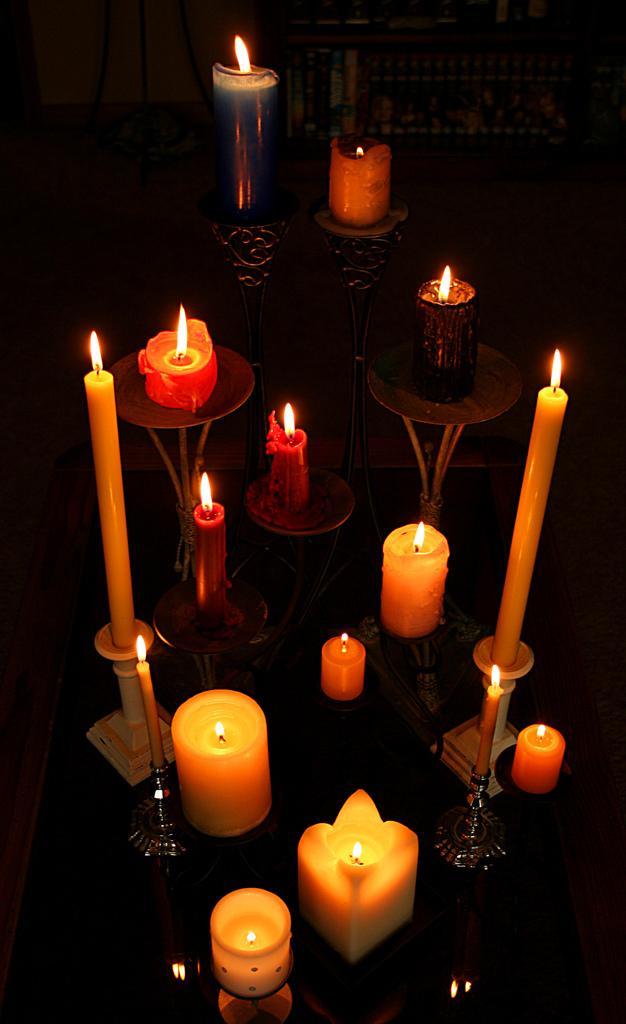In one or two sentences, can you explain what this image depicts? In the foreground of this picture, there are few candles and some of them on candle holder on the surface. 